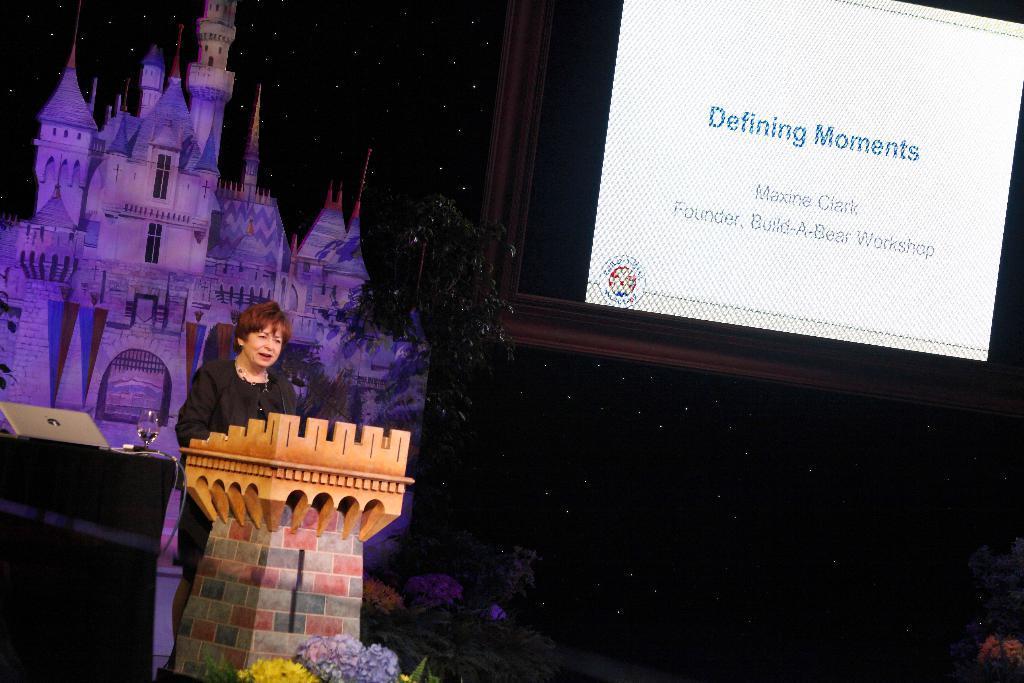Can you describe this image briefly? In this image, we can see a person in front of the podium. There is a table in the bottom left of the image contains laptop and glass. There is a cutout on the left side of the image. There is a branch in the middle of the image. There is a text in the top right of the image. 